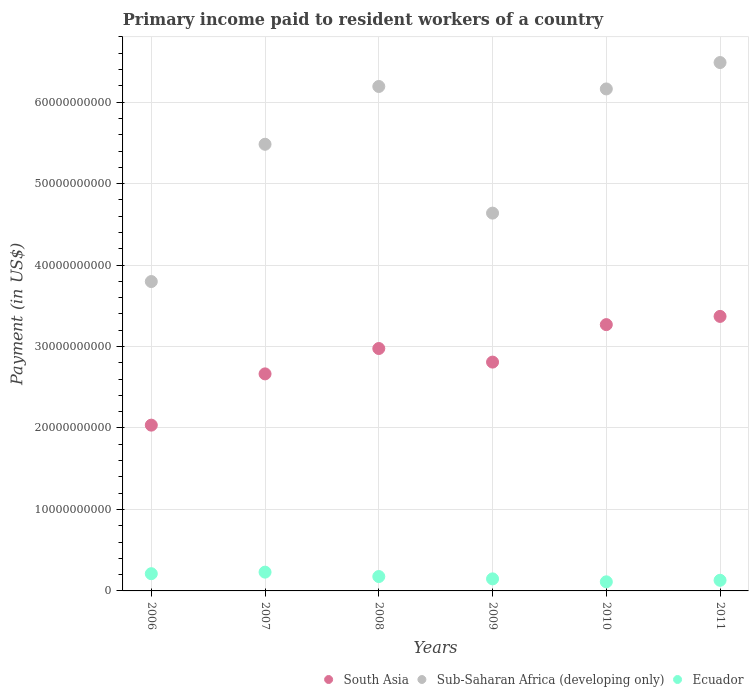How many different coloured dotlines are there?
Ensure brevity in your answer.  3. What is the amount paid to workers in Sub-Saharan Africa (developing only) in 2011?
Provide a succinct answer. 6.49e+1. Across all years, what is the maximum amount paid to workers in Ecuador?
Offer a very short reply. 2.31e+09. Across all years, what is the minimum amount paid to workers in South Asia?
Keep it short and to the point. 2.04e+1. What is the total amount paid to workers in Sub-Saharan Africa (developing only) in the graph?
Ensure brevity in your answer.  3.28e+11. What is the difference between the amount paid to workers in Ecuador in 2008 and that in 2010?
Provide a short and direct response. 6.50e+08. What is the difference between the amount paid to workers in South Asia in 2011 and the amount paid to workers in Ecuador in 2007?
Your response must be concise. 3.14e+1. What is the average amount paid to workers in Sub-Saharan Africa (developing only) per year?
Offer a very short reply. 5.46e+1. In the year 2007, what is the difference between the amount paid to workers in Ecuador and amount paid to workers in Sub-Saharan Africa (developing only)?
Your answer should be very brief. -5.25e+1. What is the ratio of the amount paid to workers in Ecuador in 2006 to that in 2010?
Keep it short and to the point. 1.89. Is the difference between the amount paid to workers in Ecuador in 2009 and 2010 greater than the difference between the amount paid to workers in Sub-Saharan Africa (developing only) in 2009 and 2010?
Your response must be concise. Yes. What is the difference between the highest and the second highest amount paid to workers in South Asia?
Offer a terse response. 1.01e+09. What is the difference between the highest and the lowest amount paid to workers in Sub-Saharan Africa (developing only)?
Keep it short and to the point. 2.69e+1. Does the amount paid to workers in Sub-Saharan Africa (developing only) monotonically increase over the years?
Provide a short and direct response. No. Is the amount paid to workers in Sub-Saharan Africa (developing only) strictly greater than the amount paid to workers in South Asia over the years?
Keep it short and to the point. Yes. Is the amount paid to workers in South Asia strictly less than the amount paid to workers in Ecuador over the years?
Provide a succinct answer. No. How many dotlines are there?
Ensure brevity in your answer.  3. What is the difference between two consecutive major ticks on the Y-axis?
Offer a terse response. 1.00e+1. Are the values on the major ticks of Y-axis written in scientific E-notation?
Your answer should be compact. No. Does the graph contain any zero values?
Give a very brief answer. No. Does the graph contain grids?
Provide a short and direct response. Yes. How are the legend labels stacked?
Make the answer very short. Horizontal. What is the title of the graph?
Give a very brief answer. Primary income paid to resident workers of a country. Does "Malaysia" appear as one of the legend labels in the graph?
Make the answer very short. No. What is the label or title of the X-axis?
Make the answer very short. Years. What is the label or title of the Y-axis?
Your answer should be very brief. Payment (in US$). What is the Payment (in US$) in South Asia in 2006?
Your answer should be very brief. 2.04e+1. What is the Payment (in US$) of Sub-Saharan Africa (developing only) in 2006?
Make the answer very short. 3.80e+1. What is the Payment (in US$) of Ecuador in 2006?
Give a very brief answer. 2.11e+09. What is the Payment (in US$) in South Asia in 2007?
Ensure brevity in your answer.  2.66e+1. What is the Payment (in US$) in Sub-Saharan Africa (developing only) in 2007?
Give a very brief answer. 5.48e+1. What is the Payment (in US$) of Ecuador in 2007?
Make the answer very short. 2.31e+09. What is the Payment (in US$) in South Asia in 2008?
Offer a very short reply. 2.98e+1. What is the Payment (in US$) of Sub-Saharan Africa (developing only) in 2008?
Offer a very short reply. 6.19e+1. What is the Payment (in US$) in Ecuador in 2008?
Ensure brevity in your answer.  1.77e+09. What is the Payment (in US$) in South Asia in 2009?
Offer a very short reply. 2.81e+1. What is the Payment (in US$) in Sub-Saharan Africa (developing only) in 2009?
Provide a succinct answer. 4.64e+1. What is the Payment (in US$) in Ecuador in 2009?
Keep it short and to the point. 1.48e+09. What is the Payment (in US$) of South Asia in 2010?
Your answer should be very brief. 3.27e+1. What is the Payment (in US$) of Sub-Saharan Africa (developing only) in 2010?
Keep it short and to the point. 6.16e+1. What is the Payment (in US$) in Ecuador in 2010?
Offer a terse response. 1.12e+09. What is the Payment (in US$) of South Asia in 2011?
Your response must be concise. 3.37e+1. What is the Payment (in US$) in Sub-Saharan Africa (developing only) in 2011?
Make the answer very short. 6.49e+1. What is the Payment (in US$) of Ecuador in 2011?
Your answer should be very brief. 1.30e+09. Across all years, what is the maximum Payment (in US$) of South Asia?
Ensure brevity in your answer.  3.37e+1. Across all years, what is the maximum Payment (in US$) in Sub-Saharan Africa (developing only)?
Provide a succinct answer. 6.49e+1. Across all years, what is the maximum Payment (in US$) of Ecuador?
Your answer should be very brief. 2.31e+09. Across all years, what is the minimum Payment (in US$) in South Asia?
Your answer should be compact. 2.04e+1. Across all years, what is the minimum Payment (in US$) of Sub-Saharan Africa (developing only)?
Provide a short and direct response. 3.80e+1. Across all years, what is the minimum Payment (in US$) of Ecuador?
Your response must be concise. 1.12e+09. What is the total Payment (in US$) of South Asia in the graph?
Your answer should be very brief. 1.71e+11. What is the total Payment (in US$) of Sub-Saharan Africa (developing only) in the graph?
Your response must be concise. 3.28e+11. What is the total Payment (in US$) of Ecuador in the graph?
Ensure brevity in your answer.  1.01e+1. What is the difference between the Payment (in US$) of South Asia in 2006 and that in 2007?
Provide a succinct answer. -6.29e+09. What is the difference between the Payment (in US$) of Sub-Saharan Africa (developing only) in 2006 and that in 2007?
Your answer should be compact. -1.69e+1. What is the difference between the Payment (in US$) of Ecuador in 2006 and that in 2007?
Provide a succinct answer. -1.91e+08. What is the difference between the Payment (in US$) of South Asia in 2006 and that in 2008?
Give a very brief answer. -9.41e+09. What is the difference between the Payment (in US$) in Sub-Saharan Africa (developing only) in 2006 and that in 2008?
Offer a very short reply. -2.39e+1. What is the difference between the Payment (in US$) in Ecuador in 2006 and that in 2008?
Offer a very short reply. 3.48e+08. What is the difference between the Payment (in US$) in South Asia in 2006 and that in 2009?
Your answer should be compact. -7.74e+09. What is the difference between the Payment (in US$) in Sub-Saharan Africa (developing only) in 2006 and that in 2009?
Keep it short and to the point. -8.40e+09. What is the difference between the Payment (in US$) in Ecuador in 2006 and that in 2009?
Ensure brevity in your answer.  6.35e+08. What is the difference between the Payment (in US$) of South Asia in 2006 and that in 2010?
Provide a succinct answer. -1.23e+1. What is the difference between the Payment (in US$) in Sub-Saharan Africa (developing only) in 2006 and that in 2010?
Make the answer very short. -2.36e+1. What is the difference between the Payment (in US$) in Ecuador in 2006 and that in 2010?
Offer a very short reply. 9.98e+08. What is the difference between the Payment (in US$) of South Asia in 2006 and that in 2011?
Provide a short and direct response. -1.33e+1. What is the difference between the Payment (in US$) in Sub-Saharan Africa (developing only) in 2006 and that in 2011?
Your answer should be compact. -2.69e+1. What is the difference between the Payment (in US$) in Ecuador in 2006 and that in 2011?
Offer a terse response. 8.10e+08. What is the difference between the Payment (in US$) of South Asia in 2007 and that in 2008?
Offer a very short reply. -3.11e+09. What is the difference between the Payment (in US$) in Sub-Saharan Africa (developing only) in 2007 and that in 2008?
Provide a short and direct response. -7.09e+09. What is the difference between the Payment (in US$) of Ecuador in 2007 and that in 2008?
Give a very brief answer. 5.40e+08. What is the difference between the Payment (in US$) of South Asia in 2007 and that in 2009?
Your response must be concise. -1.45e+09. What is the difference between the Payment (in US$) in Sub-Saharan Africa (developing only) in 2007 and that in 2009?
Keep it short and to the point. 8.45e+09. What is the difference between the Payment (in US$) of Ecuador in 2007 and that in 2009?
Your answer should be very brief. 8.27e+08. What is the difference between the Payment (in US$) of South Asia in 2007 and that in 2010?
Give a very brief answer. -6.05e+09. What is the difference between the Payment (in US$) in Sub-Saharan Africa (developing only) in 2007 and that in 2010?
Your response must be concise. -6.79e+09. What is the difference between the Payment (in US$) of Ecuador in 2007 and that in 2010?
Provide a short and direct response. 1.19e+09. What is the difference between the Payment (in US$) of South Asia in 2007 and that in 2011?
Your answer should be compact. -7.06e+09. What is the difference between the Payment (in US$) in Sub-Saharan Africa (developing only) in 2007 and that in 2011?
Provide a short and direct response. -1.00e+1. What is the difference between the Payment (in US$) in Ecuador in 2007 and that in 2011?
Your answer should be compact. 1.00e+09. What is the difference between the Payment (in US$) in South Asia in 2008 and that in 2009?
Keep it short and to the point. 1.67e+09. What is the difference between the Payment (in US$) in Sub-Saharan Africa (developing only) in 2008 and that in 2009?
Give a very brief answer. 1.55e+1. What is the difference between the Payment (in US$) of Ecuador in 2008 and that in 2009?
Your answer should be compact. 2.87e+08. What is the difference between the Payment (in US$) in South Asia in 2008 and that in 2010?
Provide a succinct answer. -2.93e+09. What is the difference between the Payment (in US$) in Sub-Saharan Africa (developing only) in 2008 and that in 2010?
Give a very brief answer. 3.02e+08. What is the difference between the Payment (in US$) of Ecuador in 2008 and that in 2010?
Keep it short and to the point. 6.50e+08. What is the difference between the Payment (in US$) of South Asia in 2008 and that in 2011?
Your response must be concise. -3.94e+09. What is the difference between the Payment (in US$) of Sub-Saharan Africa (developing only) in 2008 and that in 2011?
Keep it short and to the point. -2.94e+09. What is the difference between the Payment (in US$) of Ecuador in 2008 and that in 2011?
Keep it short and to the point. 4.61e+08. What is the difference between the Payment (in US$) of South Asia in 2009 and that in 2010?
Provide a succinct answer. -4.60e+09. What is the difference between the Payment (in US$) of Sub-Saharan Africa (developing only) in 2009 and that in 2010?
Make the answer very short. -1.52e+1. What is the difference between the Payment (in US$) of Ecuador in 2009 and that in 2010?
Offer a terse response. 3.63e+08. What is the difference between the Payment (in US$) in South Asia in 2009 and that in 2011?
Offer a terse response. -5.61e+09. What is the difference between the Payment (in US$) of Sub-Saharan Africa (developing only) in 2009 and that in 2011?
Provide a succinct answer. -1.85e+1. What is the difference between the Payment (in US$) in Ecuador in 2009 and that in 2011?
Give a very brief answer. 1.74e+08. What is the difference between the Payment (in US$) in South Asia in 2010 and that in 2011?
Make the answer very short. -1.01e+09. What is the difference between the Payment (in US$) of Sub-Saharan Africa (developing only) in 2010 and that in 2011?
Provide a short and direct response. -3.24e+09. What is the difference between the Payment (in US$) in Ecuador in 2010 and that in 2011?
Offer a very short reply. -1.88e+08. What is the difference between the Payment (in US$) in South Asia in 2006 and the Payment (in US$) in Sub-Saharan Africa (developing only) in 2007?
Offer a terse response. -3.45e+1. What is the difference between the Payment (in US$) of South Asia in 2006 and the Payment (in US$) of Ecuador in 2007?
Ensure brevity in your answer.  1.80e+1. What is the difference between the Payment (in US$) in Sub-Saharan Africa (developing only) in 2006 and the Payment (in US$) in Ecuador in 2007?
Your response must be concise. 3.57e+1. What is the difference between the Payment (in US$) in South Asia in 2006 and the Payment (in US$) in Sub-Saharan Africa (developing only) in 2008?
Make the answer very short. -4.16e+1. What is the difference between the Payment (in US$) of South Asia in 2006 and the Payment (in US$) of Ecuador in 2008?
Offer a very short reply. 1.86e+1. What is the difference between the Payment (in US$) in Sub-Saharan Africa (developing only) in 2006 and the Payment (in US$) in Ecuador in 2008?
Provide a short and direct response. 3.62e+1. What is the difference between the Payment (in US$) of South Asia in 2006 and the Payment (in US$) of Sub-Saharan Africa (developing only) in 2009?
Ensure brevity in your answer.  -2.60e+1. What is the difference between the Payment (in US$) in South Asia in 2006 and the Payment (in US$) in Ecuador in 2009?
Provide a short and direct response. 1.89e+1. What is the difference between the Payment (in US$) of Sub-Saharan Africa (developing only) in 2006 and the Payment (in US$) of Ecuador in 2009?
Provide a succinct answer. 3.65e+1. What is the difference between the Payment (in US$) of South Asia in 2006 and the Payment (in US$) of Sub-Saharan Africa (developing only) in 2010?
Provide a succinct answer. -4.13e+1. What is the difference between the Payment (in US$) in South Asia in 2006 and the Payment (in US$) in Ecuador in 2010?
Ensure brevity in your answer.  1.92e+1. What is the difference between the Payment (in US$) of Sub-Saharan Africa (developing only) in 2006 and the Payment (in US$) of Ecuador in 2010?
Provide a succinct answer. 3.69e+1. What is the difference between the Payment (in US$) of South Asia in 2006 and the Payment (in US$) of Sub-Saharan Africa (developing only) in 2011?
Your answer should be compact. -4.45e+1. What is the difference between the Payment (in US$) of South Asia in 2006 and the Payment (in US$) of Ecuador in 2011?
Your answer should be very brief. 1.90e+1. What is the difference between the Payment (in US$) in Sub-Saharan Africa (developing only) in 2006 and the Payment (in US$) in Ecuador in 2011?
Make the answer very short. 3.67e+1. What is the difference between the Payment (in US$) of South Asia in 2007 and the Payment (in US$) of Sub-Saharan Africa (developing only) in 2008?
Keep it short and to the point. -3.53e+1. What is the difference between the Payment (in US$) in South Asia in 2007 and the Payment (in US$) in Ecuador in 2008?
Provide a succinct answer. 2.49e+1. What is the difference between the Payment (in US$) in Sub-Saharan Africa (developing only) in 2007 and the Payment (in US$) in Ecuador in 2008?
Provide a succinct answer. 5.31e+1. What is the difference between the Payment (in US$) in South Asia in 2007 and the Payment (in US$) in Sub-Saharan Africa (developing only) in 2009?
Offer a very short reply. -1.97e+1. What is the difference between the Payment (in US$) in South Asia in 2007 and the Payment (in US$) in Ecuador in 2009?
Ensure brevity in your answer.  2.52e+1. What is the difference between the Payment (in US$) in Sub-Saharan Africa (developing only) in 2007 and the Payment (in US$) in Ecuador in 2009?
Provide a succinct answer. 5.33e+1. What is the difference between the Payment (in US$) of South Asia in 2007 and the Payment (in US$) of Sub-Saharan Africa (developing only) in 2010?
Your answer should be compact. -3.50e+1. What is the difference between the Payment (in US$) of South Asia in 2007 and the Payment (in US$) of Ecuador in 2010?
Your response must be concise. 2.55e+1. What is the difference between the Payment (in US$) in Sub-Saharan Africa (developing only) in 2007 and the Payment (in US$) in Ecuador in 2010?
Offer a terse response. 5.37e+1. What is the difference between the Payment (in US$) of South Asia in 2007 and the Payment (in US$) of Sub-Saharan Africa (developing only) in 2011?
Provide a succinct answer. -3.82e+1. What is the difference between the Payment (in US$) of South Asia in 2007 and the Payment (in US$) of Ecuador in 2011?
Provide a short and direct response. 2.53e+1. What is the difference between the Payment (in US$) in Sub-Saharan Africa (developing only) in 2007 and the Payment (in US$) in Ecuador in 2011?
Your answer should be compact. 5.35e+1. What is the difference between the Payment (in US$) in South Asia in 2008 and the Payment (in US$) in Sub-Saharan Africa (developing only) in 2009?
Offer a terse response. -1.66e+1. What is the difference between the Payment (in US$) of South Asia in 2008 and the Payment (in US$) of Ecuador in 2009?
Ensure brevity in your answer.  2.83e+1. What is the difference between the Payment (in US$) in Sub-Saharan Africa (developing only) in 2008 and the Payment (in US$) in Ecuador in 2009?
Your response must be concise. 6.04e+1. What is the difference between the Payment (in US$) in South Asia in 2008 and the Payment (in US$) in Sub-Saharan Africa (developing only) in 2010?
Ensure brevity in your answer.  -3.19e+1. What is the difference between the Payment (in US$) in South Asia in 2008 and the Payment (in US$) in Ecuador in 2010?
Provide a short and direct response. 2.86e+1. What is the difference between the Payment (in US$) of Sub-Saharan Africa (developing only) in 2008 and the Payment (in US$) of Ecuador in 2010?
Ensure brevity in your answer.  6.08e+1. What is the difference between the Payment (in US$) in South Asia in 2008 and the Payment (in US$) in Sub-Saharan Africa (developing only) in 2011?
Ensure brevity in your answer.  -3.51e+1. What is the difference between the Payment (in US$) of South Asia in 2008 and the Payment (in US$) of Ecuador in 2011?
Give a very brief answer. 2.85e+1. What is the difference between the Payment (in US$) in Sub-Saharan Africa (developing only) in 2008 and the Payment (in US$) in Ecuador in 2011?
Keep it short and to the point. 6.06e+1. What is the difference between the Payment (in US$) in South Asia in 2009 and the Payment (in US$) in Sub-Saharan Africa (developing only) in 2010?
Offer a terse response. -3.35e+1. What is the difference between the Payment (in US$) in South Asia in 2009 and the Payment (in US$) in Ecuador in 2010?
Provide a succinct answer. 2.70e+1. What is the difference between the Payment (in US$) in Sub-Saharan Africa (developing only) in 2009 and the Payment (in US$) in Ecuador in 2010?
Your answer should be very brief. 4.53e+1. What is the difference between the Payment (in US$) in South Asia in 2009 and the Payment (in US$) in Sub-Saharan Africa (developing only) in 2011?
Your answer should be compact. -3.68e+1. What is the difference between the Payment (in US$) in South Asia in 2009 and the Payment (in US$) in Ecuador in 2011?
Your answer should be compact. 2.68e+1. What is the difference between the Payment (in US$) of Sub-Saharan Africa (developing only) in 2009 and the Payment (in US$) of Ecuador in 2011?
Keep it short and to the point. 4.51e+1. What is the difference between the Payment (in US$) of South Asia in 2010 and the Payment (in US$) of Sub-Saharan Africa (developing only) in 2011?
Provide a succinct answer. -3.22e+1. What is the difference between the Payment (in US$) of South Asia in 2010 and the Payment (in US$) of Ecuador in 2011?
Your answer should be very brief. 3.14e+1. What is the difference between the Payment (in US$) of Sub-Saharan Africa (developing only) in 2010 and the Payment (in US$) of Ecuador in 2011?
Your response must be concise. 6.03e+1. What is the average Payment (in US$) of South Asia per year?
Offer a very short reply. 2.85e+1. What is the average Payment (in US$) in Sub-Saharan Africa (developing only) per year?
Make the answer very short. 5.46e+1. What is the average Payment (in US$) in Ecuador per year?
Provide a short and direct response. 1.68e+09. In the year 2006, what is the difference between the Payment (in US$) of South Asia and Payment (in US$) of Sub-Saharan Africa (developing only)?
Give a very brief answer. -1.76e+1. In the year 2006, what is the difference between the Payment (in US$) in South Asia and Payment (in US$) in Ecuador?
Keep it short and to the point. 1.82e+1. In the year 2006, what is the difference between the Payment (in US$) of Sub-Saharan Africa (developing only) and Payment (in US$) of Ecuador?
Ensure brevity in your answer.  3.59e+1. In the year 2007, what is the difference between the Payment (in US$) of South Asia and Payment (in US$) of Sub-Saharan Africa (developing only)?
Offer a very short reply. -2.82e+1. In the year 2007, what is the difference between the Payment (in US$) of South Asia and Payment (in US$) of Ecuador?
Give a very brief answer. 2.43e+1. In the year 2007, what is the difference between the Payment (in US$) of Sub-Saharan Africa (developing only) and Payment (in US$) of Ecuador?
Offer a very short reply. 5.25e+1. In the year 2008, what is the difference between the Payment (in US$) in South Asia and Payment (in US$) in Sub-Saharan Africa (developing only)?
Provide a short and direct response. -3.22e+1. In the year 2008, what is the difference between the Payment (in US$) in South Asia and Payment (in US$) in Ecuador?
Ensure brevity in your answer.  2.80e+1. In the year 2008, what is the difference between the Payment (in US$) in Sub-Saharan Africa (developing only) and Payment (in US$) in Ecuador?
Offer a very short reply. 6.02e+1. In the year 2009, what is the difference between the Payment (in US$) in South Asia and Payment (in US$) in Sub-Saharan Africa (developing only)?
Offer a very short reply. -1.83e+1. In the year 2009, what is the difference between the Payment (in US$) in South Asia and Payment (in US$) in Ecuador?
Ensure brevity in your answer.  2.66e+1. In the year 2009, what is the difference between the Payment (in US$) in Sub-Saharan Africa (developing only) and Payment (in US$) in Ecuador?
Offer a very short reply. 4.49e+1. In the year 2010, what is the difference between the Payment (in US$) in South Asia and Payment (in US$) in Sub-Saharan Africa (developing only)?
Provide a short and direct response. -2.89e+1. In the year 2010, what is the difference between the Payment (in US$) of South Asia and Payment (in US$) of Ecuador?
Make the answer very short. 3.16e+1. In the year 2010, what is the difference between the Payment (in US$) of Sub-Saharan Africa (developing only) and Payment (in US$) of Ecuador?
Your response must be concise. 6.05e+1. In the year 2011, what is the difference between the Payment (in US$) in South Asia and Payment (in US$) in Sub-Saharan Africa (developing only)?
Provide a short and direct response. -3.12e+1. In the year 2011, what is the difference between the Payment (in US$) in South Asia and Payment (in US$) in Ecuador?
Offer a terse response. 3.24e+1. In the year 2011, what is the difference between the Payment (in US$) of Sub-Saharan Africa (developing only) and Payment (in US$) of Ecuador?
Offer a very short reply. 6.36e+1. What is the ratio of the Payment (in US$) of South Asia in 2006 to that in 2007?
Provide a short and direct response. 0.76. What is the ratio of the Payment (in US$) in Sub-Saharan Africa (developing only) in 2006 to that in 2007?
Provide a short and direct response. 0.69. What is the ratio of the Payment (in US$) in Ecuador in 2006 to that in 2007?
Your response must be concise. 0.92. What is the ratio of the Payment (in US$) in South Asia in 2006 to that in 2008?
Provide a succinct answer. 0.68. What is the ratio of the Payment (in US$) of Sub-Saharan Africa (developing only) in 2006 to that in 2008?
Ensure brevity in your answer.  0.61. What is the ratio of the Payment (in US$) of Ecuador in 2006 to that in 2008?
Keep it short and to the point. 1.2. What is the ratio of the Payment (in US$) of South Asia in 2006 to that in 2009?
Make the answer very short. 0.72. What is the ratio of the Payment (in US$) in Sub-Saharan Africa (developing only) in 2006 to that in 2009?
Ensure brevity in your answer.  0.82. What is the ratio of the Payment (in US$) of Ecuador in 2006 to that in 2009?
Offer a very short reply. 1.43. What is the ratio of the Payment (in US$) of South Asia in 2006 to that in 2010?
Make the answer very short. 0.62. What is the ratio of the Payment (in US$) of Sub-Saharan Africa (developing only) in 2006 to that in 2010?
Make the answer very short. 0.62. What is the ratio of the Payment (in US$) of Ecuador in 2006 to that in 2010?
Offer a very short reply. 1.89. What is the ratio of the Payment (in US$) of South Asia in 2006 to that in 2011?
Provide a succinct answer. 0.6. What is the ratio of the Payment (in US$) of Sub-Saharan Africa (developing only) in 2006 to that in 2011?
Keep it short and to the point. 0.59. What is the ratio of the Payment (in US$) in Ecuador in 2006 to that in 2011?
Provide a short and direct response. 1.62. What is the ratio of the Payment (in US$) in South Asia in 2007 to that in 2008?
Provide a succinct answer. 0.9. What is the ratio of the Payment (in US$) of Sub-Saharan Africa (developing only) in 2007 to that in 2008?
Provide a short and direct response. 0.89. What is the ratio of the Payment (in US$) of Ecuador in 2007 to that in 2008?
Your answer should be compact. 1.31. What is the ratio of the Payment (in US$) in South Asia in 2007 to that in 2009?
Give a very brief answer. 0.95. What is the ratio of the Payment (in US$) of Sub-Saharan Africa (developing only) in 2007 to that in 2009?
Your answer should be compact. 1.18. What is the ratio of the Payment (in US$) in Ecuador in 2007 to that in 2009?
Your answer should be compact. 1.56. What is the ratio of the Payment (in US$) in South Asia in 2007 to that in 2010?
Keep it short and to the point. 0.81. What is the ratio of the Payment (in US$) of Sub-Saharan Africa (developing only) in 2007 to that in 2010?
Provide a succinct answer. 0.89. What is the ratio of the Payment (in US$) in Ecuador in 2007 to that in 2010?
Offer a very short reply. 2.07. What is the ratio of the Payment (in US$) of South Asia in 2007 to that in 2011?
Provide a succinct answer. 0.79. What is the ratio of the Payment (in US$) of Sub-Saharan Africa (developing only) in 2007 to that in 2011?
Provide a short and direct response. 0.85. What is the ratio of the Payment (in US$) of Ecuador in 2007 to that in 2011?
Offer a very short reply. 1.77. What is the ratio of the Payment (in US$) in South Asia in 2008 to that in 2009?
Offer a terse response. 1.06. What is the ratio of the Payment (in US$) of Sub-Saharan Africa (developing only) in 2008 to that in 2009?
Make the answer very short. 1.34. What is the ratio of the Payment (in US$) of Ecuador in 2008 to that in 2009?
Your answer should be compact. 1.19. What is the ratio of the Payment (in US$) of South Asia in 2008 to that in 2010?
Provide a succinct answer. 0.91. What is the ratio of the Payment (in US$) in Ecuador in 2008 to that in 2010?
Give a very brief answer. 1.58. What is the ratio of the Payment (in US$) of South Asia in 2008 to that in 2011?
Ensure brevity in your answer.  0.88. What is the ratio of the Payment (in US$) of Sub-Saharan Africa (developing only) in 2008 to that in 2011?
Keep it short and to the point. 0.95. What is the ratio of the Payment (in US$) in Ecuador in 2008 to that in 2011?
Provide a short and direct response. 1.35. What is the ratio of the Payment (in US$) in South Asia in 2009 to that in 2010?
Make the answer very short. 0.86. What is the ratio of the Payment (in US$) of Sub-Saharan Africa (developing only) in 2009 to that in 2010?
Ensure brevity in your answer.  0.75. What is the ratio of the Payment (in US$) in Ecuador in 2009 to that in 2010?
Your answer should be very brief. 1.32. What is the ratio of the Payment (in US$) of South Asia in 2009 to that in 2011?
Your answer should be very brief. 0.83. What is the ratio of the Payment (in US$) in Sub-Saharan Africa (developing only) in 2009 to that in 2011?
Provide a succinct answer. 0.71. What is the ratio of the Payment (in US$) in Ecuador in 2009 to that in 2011?
Make the answer very short. 1.13. What is the ratio of the Payment (in US$) in South Asia in 2010 to that in 2011?
Offer a terse response. 0.97. What is the ratio of the Payment (in US$) in Sub-Saharan Africa (developing only) in 2010 to that in 2011?
Give a very brief answer. 0.95. What is the ratio of the Payment (in US$) in Ecuador in 2010 to that in 2011?
Make the answer very short. 0.86. What is the difference between the highest and the second highest Payment (in US$) of South Asia?
Keep it short and to the point. 1.01e+09. What is the difference between the highest and the second highest Payment (in US$) of Sub-Saharan Africa (developing only)?
Your answer should be compact. 2.94e+09. What is the difference between the highest and the second highest Payment (in US$) of Ecuador?
Provide a succinct answer. 1.91e+08. What is the difference between the highest and the lowest Payment (in US$) in South Asia?
Provide a succinct answer. 1.33e+1. What is the difference between the highest and the lowest Payment (in US$) in Sub-Saharan Africa (developing only)?
Your answer should be very brief. 2.69e+1. What is the difference between the highest and the lowest Payment (in US$) in Ecuador?
Make the answer very short. 1.19e+09. 